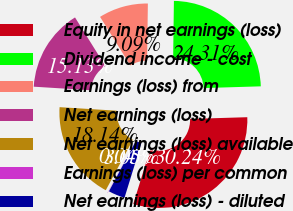<chart> <loc_0><loc_0><loc_500><loc_500><pie_chart><fcel>Equity in net earnings (loss)<fcel>Dividend income - cost<fcel>Earnings (loss) from<fcel>Net earnings (loss)<fcel>Net earnings (loss) available<fcel>Earnings (loss) per common<fcel>Net earnings (loss) - diluted<nl><fcel>30.24%<fcel>24.31%<fcel>9.09%<fcel>15.13%<fcel>18.14%<fcel>0.04%<fcel>3.05%<nl></chart> 